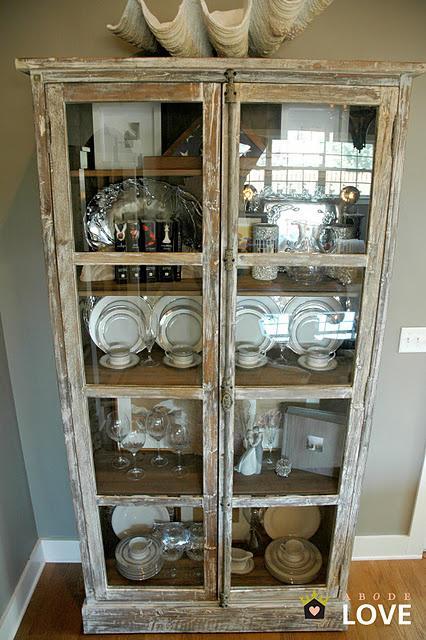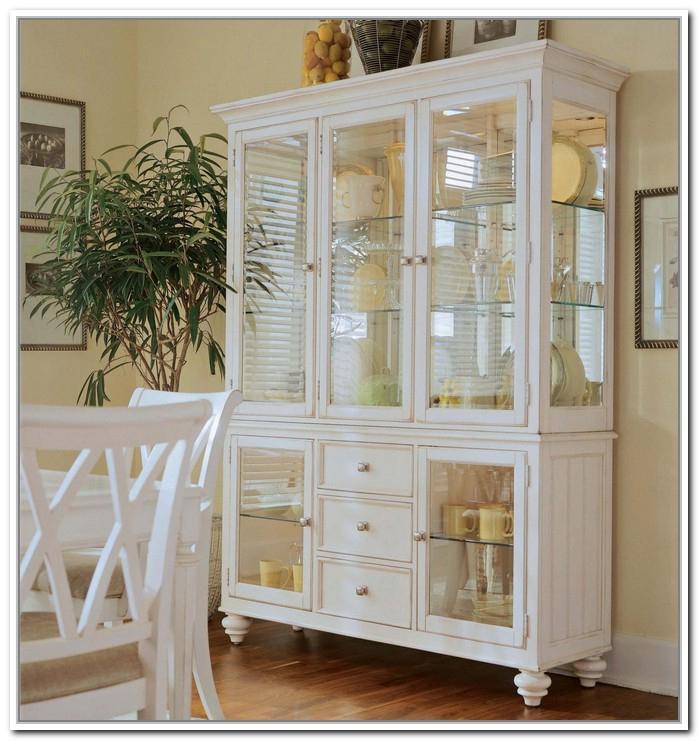The first image is the image on the left, the second image is the image on the right. Analyze the images presented: Is the assertion "There is a chair set up near a white cabinet." valid? Answer yes or no. Yes. The first image is the image on the left, the second image is the image on the right. Given the left and right images, does the statement "All of the cabinets pictured have flat tops instead of curved tops." hold true? Answer yes or no. Yes. 